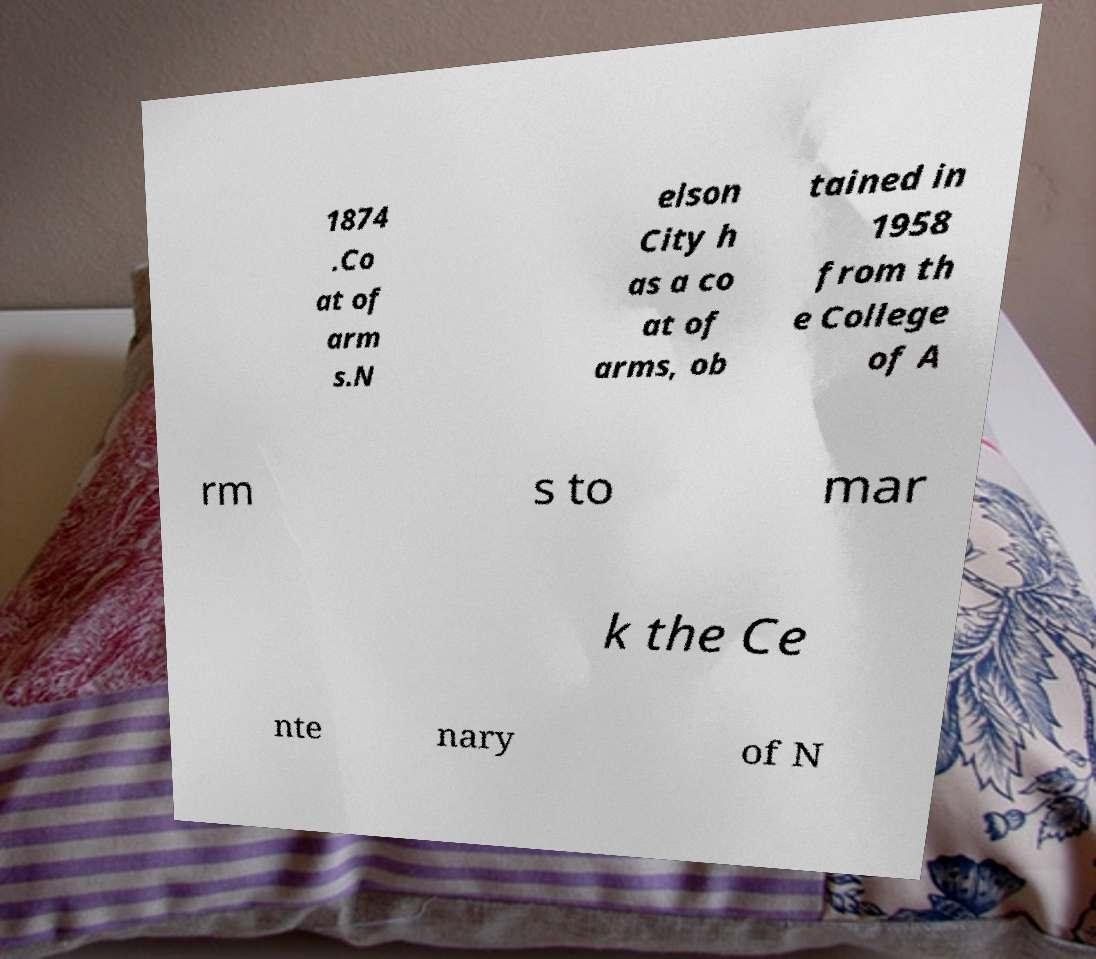Can you accurately transcribe the text from the provided image for me? 1874 .Co at of arm s.N elson City h as a co at of arms, ob tained in 1958 from th e College of A rm s to mar k the Ce nte nary of N 